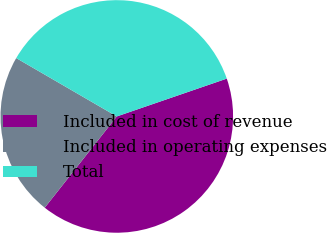<chart> <loc_0><loc_0><loc_500><loc_500><pie_chart><fcel>Included in cost of revenue<fcel>Included in operating expenses<fcel>Total<nl><fcel>40.91%<fcel>22.73%<fcel>36.36%<nl></chart> 